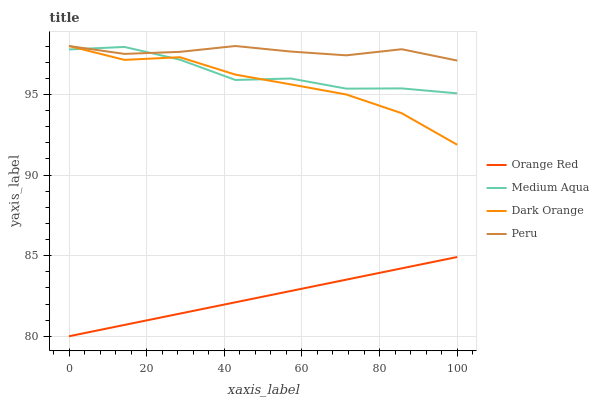Does Orange Red have the minimum area under the curve?
Answer yes or no. Yes. Does Peru have the maximum area under the curve?
Answer yes or no. Yes. Does Medium Aqua have the minimum area under the curve?
Answer yes or no. No. Does Medium Aqua have the maximum area under the curve?
Answer yes or no. No. Is Orange Red the smoothest?
Answer yes or no. Yes. Is Medium Aqua the roughest?
Answer yes or no. Yes. Is Medium Aqua the smoothest?
Answer yes or no. No. Is Orange Red the roughest?
Answer yes or no. No. Does Orange Red have the lowest value?
Answer yes or no. Yes. Does Medium Aqua have the lowest value?
Answer yes or no. No. Does Peru have the highest value?
Answer yes or no. Yes. Does Medium Aqua have the highest value?
Answer yes or no. No. Is Orange Red less than Peru?
Answer yes or no. Yes. Is Dark Orange greater than Orange Red?
Answer yes or no. Yes. Does Peru intersect Medium Aqua?
Answer yes or no. Yes. Is Peru less than Medium Aqua?
Answer yes or no. No. Is Peru greater than Medium Aqua?
Answer yes or no. No. Does Orange Red intersect Peru?
Answer yes or no. No. 